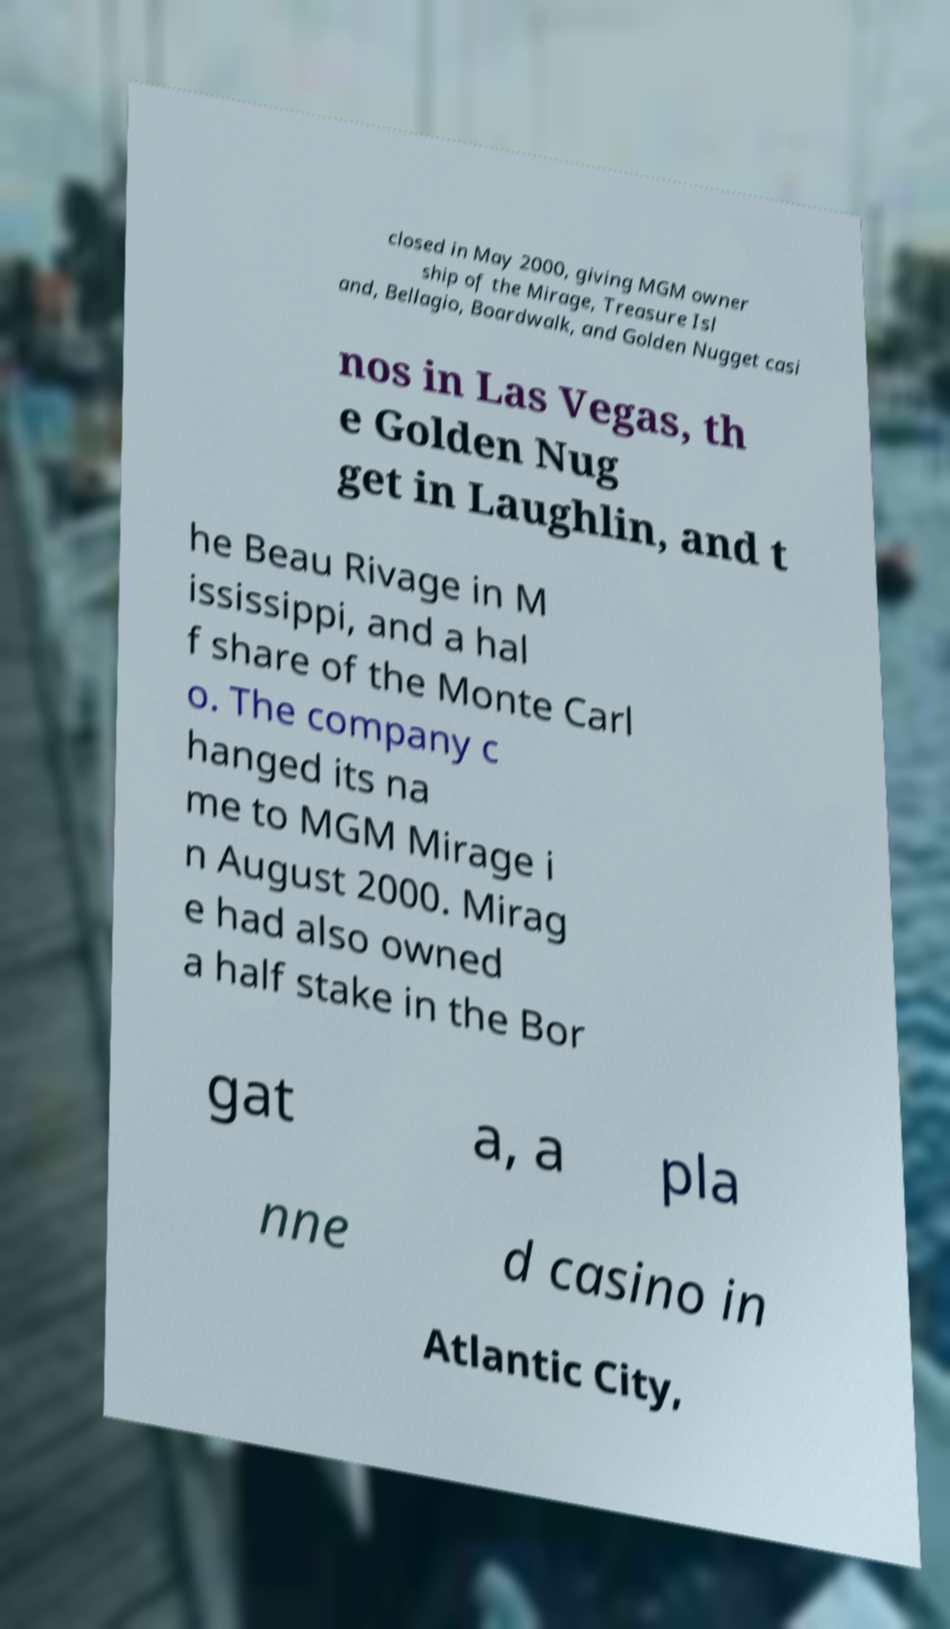For documentation purposes, I need the text within this image transcribed. Could you provide that? closed in May 2000, giving MGM owner ship of the Mirage, Treasure Isl and, Bellagio, Boardwalk, and Golden Nugget casi nos in Las Vegas, th e Golden Nug get in Laughlin, and t he Beau Rivage in M ississippi, and a hal f share of the Monte Carl o. The company c hanged its na me to MGM Mirage i n August 2000. Mirag e had also owned a half stake in the Bor gat a, a pla nne d casino in Atlantic City, 